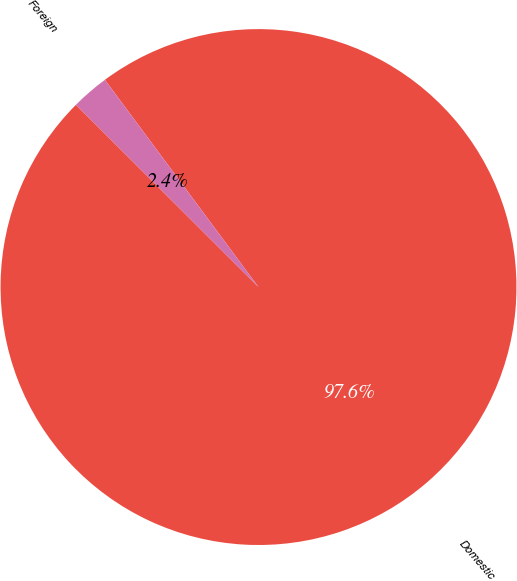<chart> <loc_0><loc_0><loc_500><loc_500><pie_chart><fcel>Domestic<fcel>Foreign<nl><fcel>97.64%<fcel>2.36%<nl></chart> 